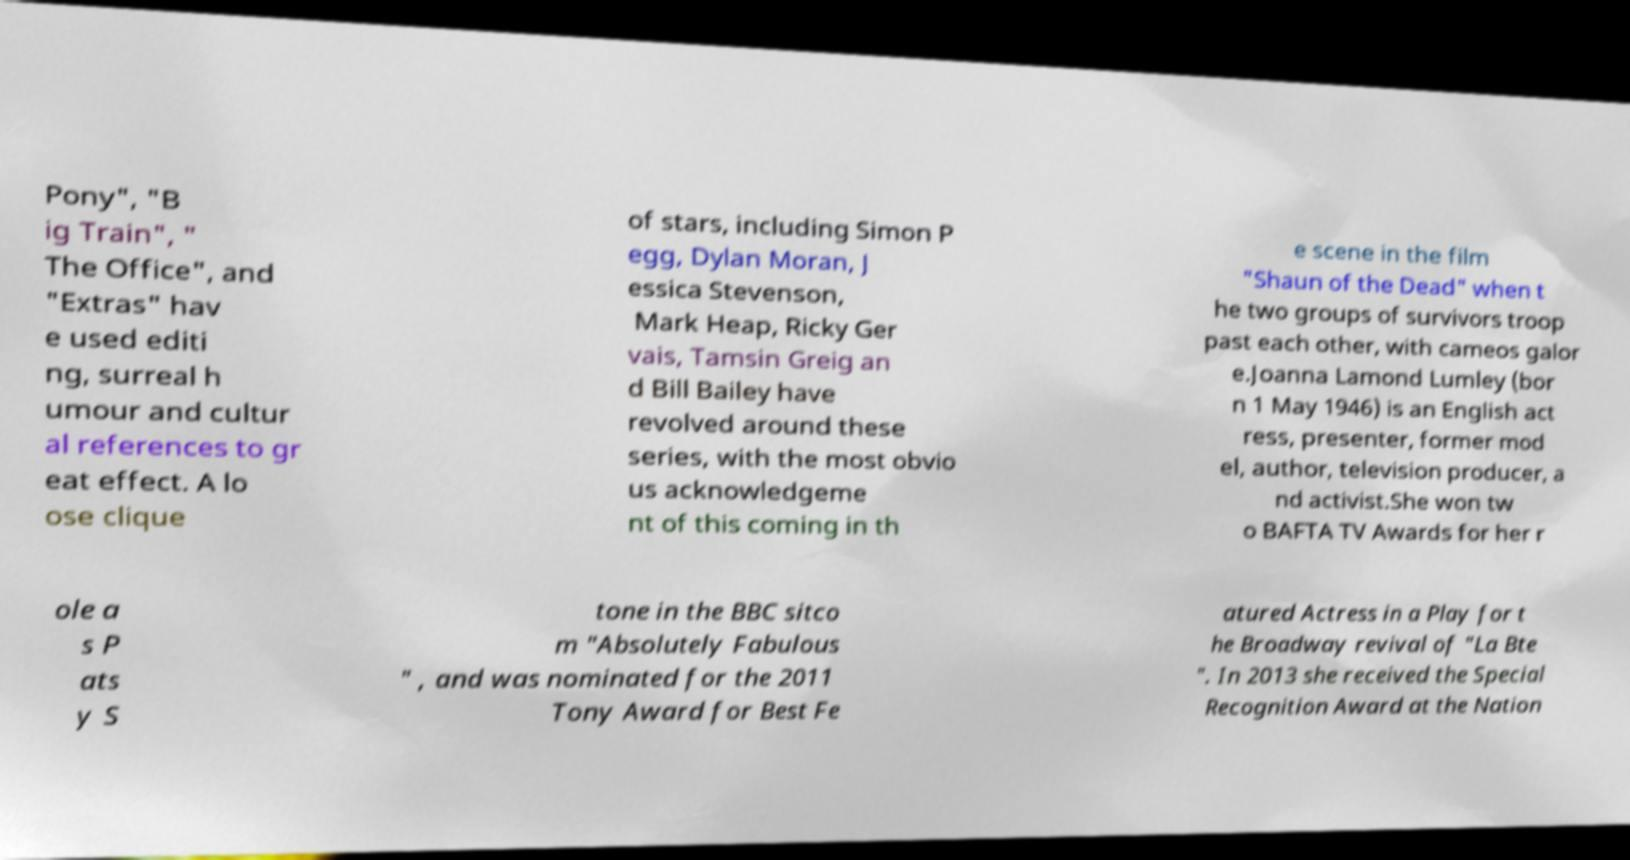There's text embedded in this image that I need extracted. Can you transcribe it verbatim? Pony", "B ig Train", " The Office", and "Extras" hav e used editi ng, surreal h umour and cultur al references to gr eat effect. A lo ose clique of stars, including Simon P egg, Dylan Moran, J essica Stevenson, Mark Heap, Ricky Ger vais, Tamsin Greig an d Bill Bailey have revolved around these series, with the most obvio us acknowledgeme nt of this coming in th e scene in the film "Shaun of the Dead" when t he two groups of survivors troop past each other, with cameos galor e.Joanna Lamond Lumley (bor n 1 May 1946) is an English act ress, presenter, former mod el, author, television producer, a nd activist.She won tw o BAFTA TV Awards for her r ole a s P ats y S tone in the BBC sitco m "Absolutely Fabulous " , and was nominated for the 2011 Tony Award for Best Fe atured Actress in a Play for t he Broadway revival of "La Bte ". In 2013 she received the Special Recognition Award at the Nation 